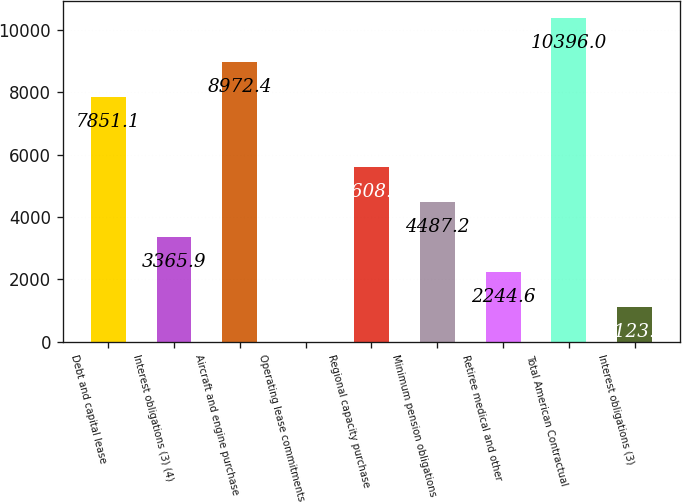Convert chart. <chart><loc_0><loc_0><loc_500><loc_500><bar_chart><fcel>Debt and capital lease<fcel>Interest obligations (3) (4)<fcel>Aircraft and engine purchase<fcel>Operating lease commitments<fcel>Regional capacity purchase<fcel>Minimum pension obligations<fcel>Retiree medical and other<fcel>Total American Contractual<fcel>Interest obligations (3)<nl><fcel>7851.1<fcel>3365.9<fcel>8972.4<fcel>2<fcel>5608.5<fcel>4487.2<fcel>2244.6<fcel>10396<fcel>1123.3<nl></chart> 